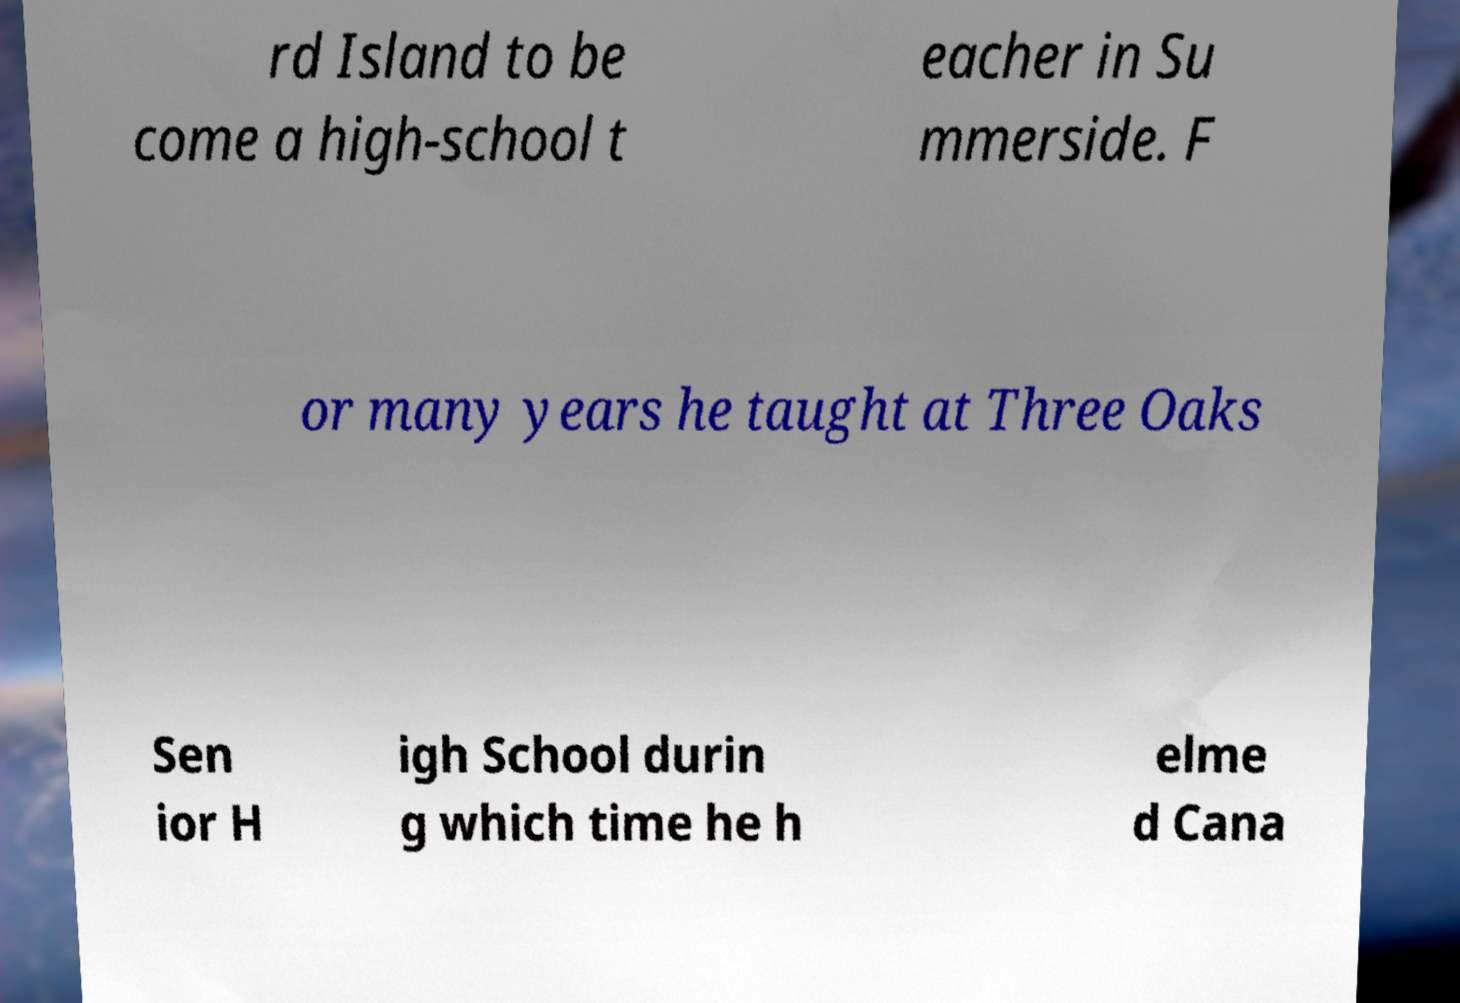Could you assist in decoding the text presented in this image and type it out clearly? rd Island to be come a high-school t eacher in Su mmerside. F or many years he taught at Three Oaks Sen ior H igh School durin g which time he h elme d Cana 